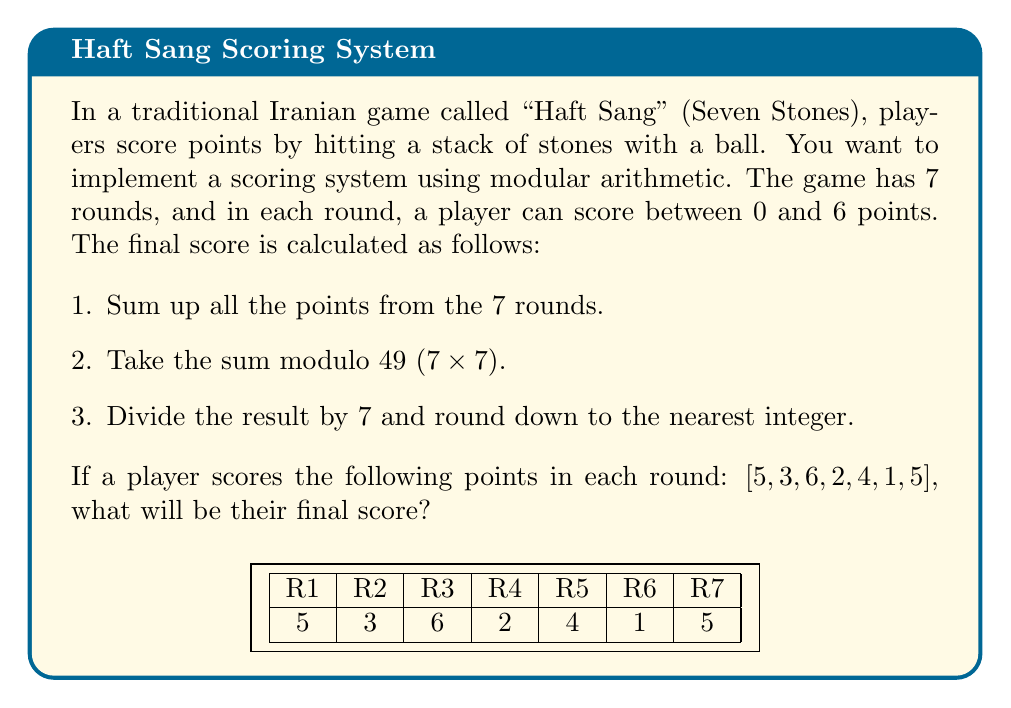Show me your answer to this math problem. Let's break this down step-by-step:

1. Sum up all the points:
   $$5 + 3 + 6 + 2 + 4 + 1 + 5 = 26$$

2. Take the sum modulo 49:
   $$26 \bmod 49 = 26$$
   (Since 26 is already less than 49, it remains unchanged)

3. Divide the result by 7 and round down:
   $$\lfloor \frac{26}{7} \rfloor = \lfloor 3.714... \rfloor = 3$$

The floor function $$\lfloor x \rfloor$$ gives the largest integer less than or equal to x.

This scoring system effectively maps the total points (0 to 42) to a score range of 0 to 6, which is suitable for a traditional game with limited scoring options. It also introduces an element of unpredictability, as small changes in individual round scores can lead to different final scores due to the modular arithmetic.
Answer: 3 